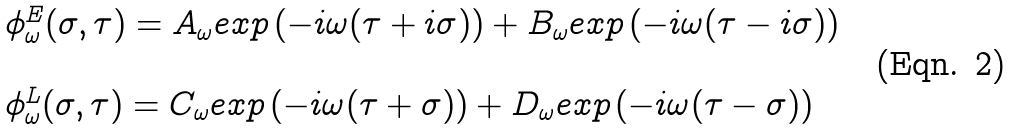Convert formula to latex. <formula><loc_0><loc_0><loc_500><loc_500>\begin{array} { l l } \phi ^ { E } _ { \omega } ( \sigma , \tau ) = A _ { \omega } e x p \, ( - i \omega ( \tau + i \sigma ) ) + B _ { \omega } e x p \, ( - i \omega ( \tau - i \sigma ) ) \\ \\ \phi ^ { L } _ { \omega } ( \sigma , \tau ) = C _ { \omega } e x p \, ( - i \omega ( \tau + \sigma ) ) + D _ { \omega } e x p \, ( - i \omega ( \tau - \sigma ) ) \end{array}</formula> 